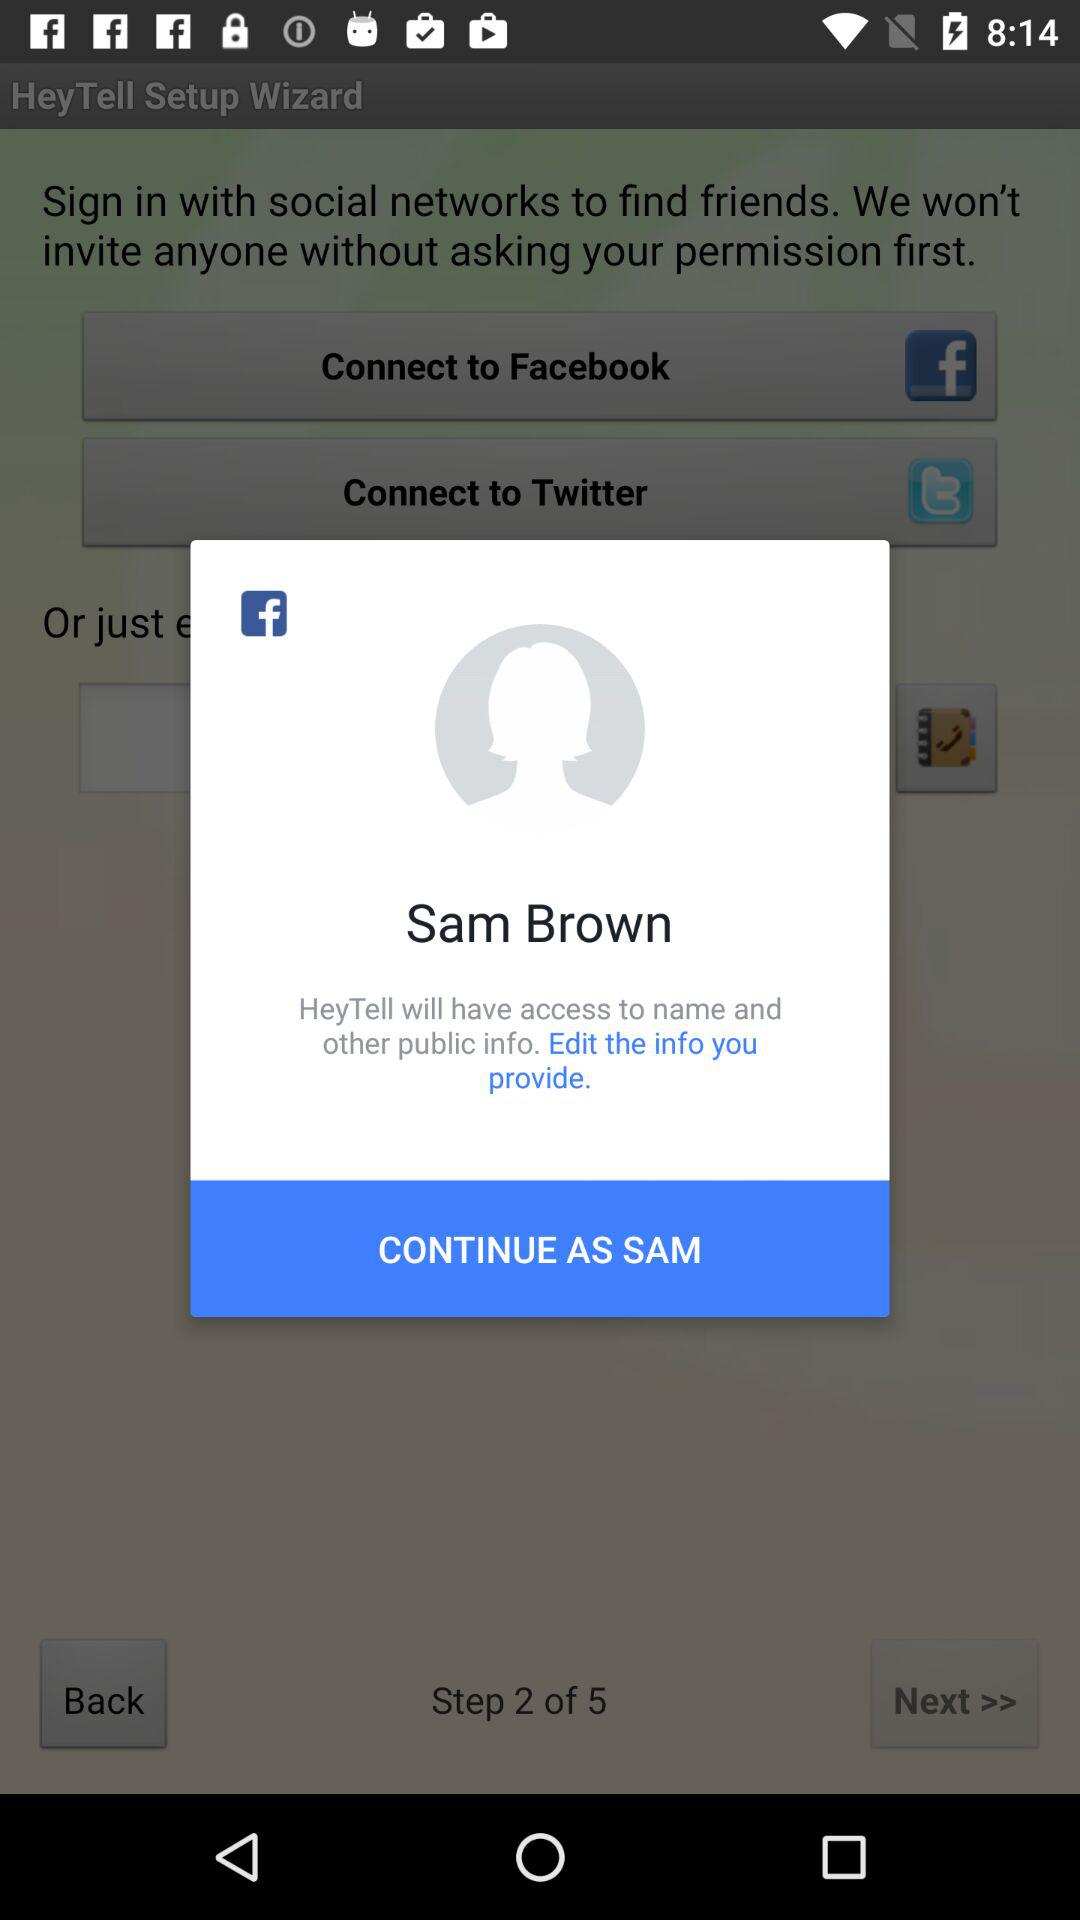What accounts can I use to sign up? You can use "Facebook" and "Twitter" accounts. 